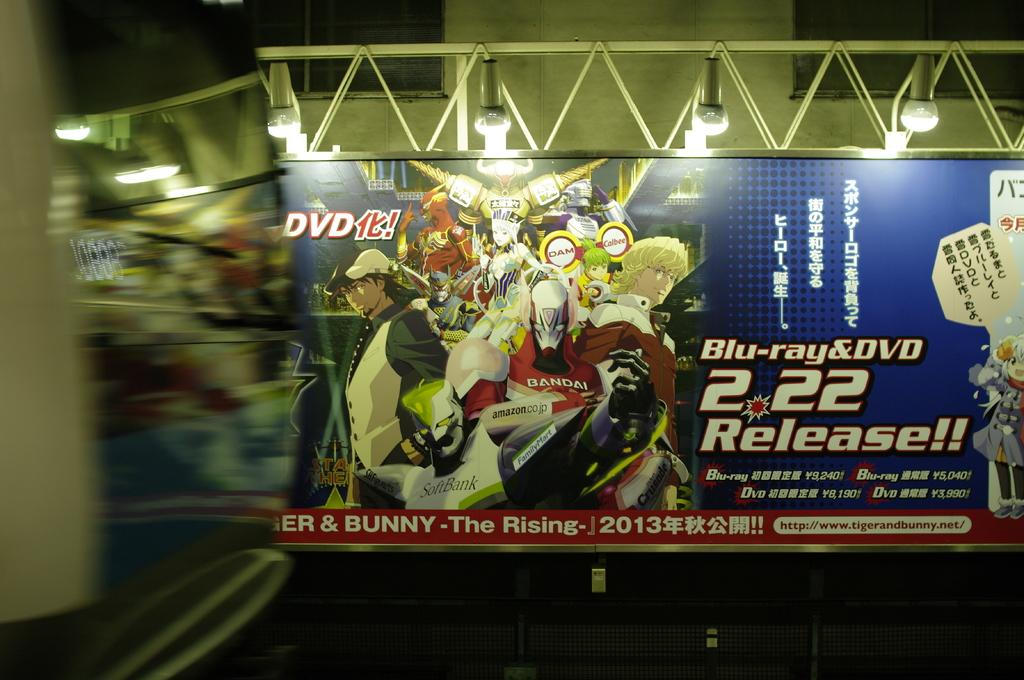<image>
Summarize the visual content of the image. A large sign, only half of which is legible, that says Bunny the Rising. 